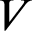Convert formula to latex. <formula><loc_0><loc_0><loc_500><loc_500>V</formula> 